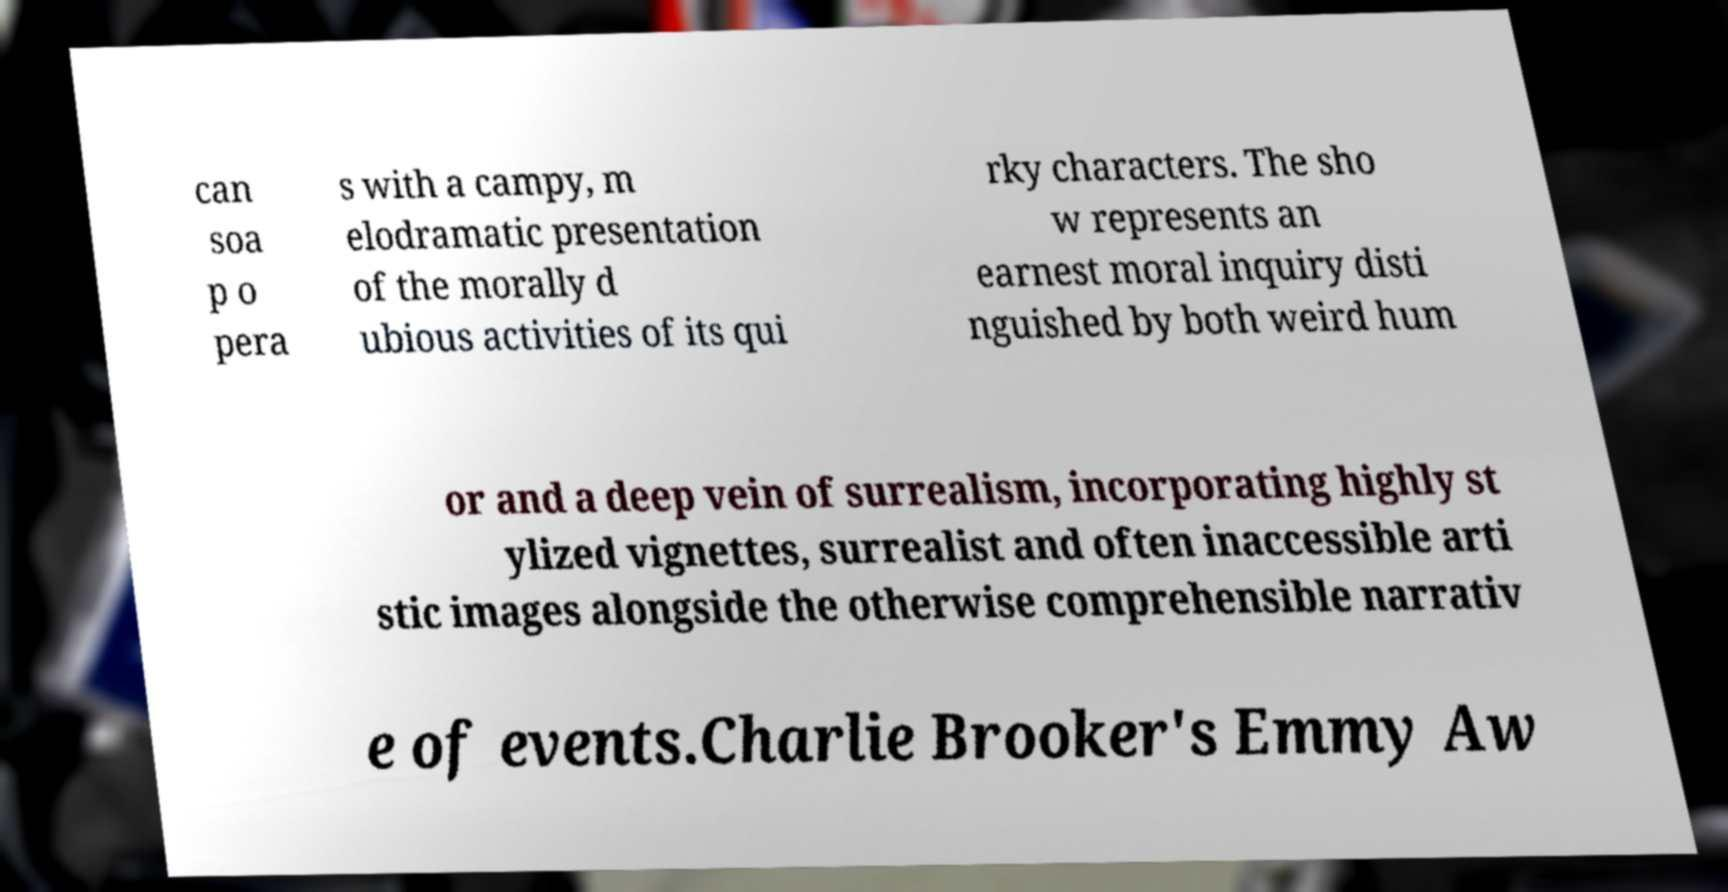Can you accurately transcribe the text from the provided image for me? can soa p o pera s with a campy, m elodramatic presentation of the morally d ubious activities of its qui rky characters. The sho w represents an earnest moral inquiry disti nguished by both weird hum or and a deep vein of surrealism, incorporating highly st ylized vignettes, surrealist and often inaccessible arti stic images alongside the otherwise comprehensible narrativ e of events.Charlie Brooker's Emmy Aw 